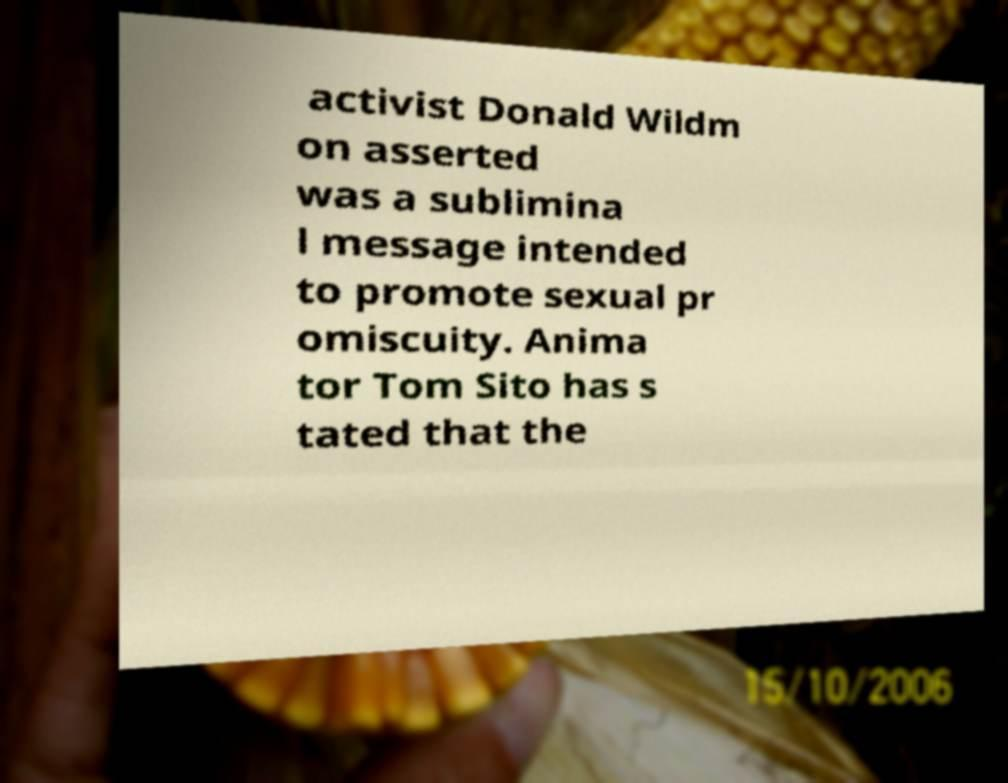I need the written content from this picture converted into text. Can you do that? activist Donald Wildm on asserted was a sublimina l message intended to promote sexual pr omiscuity. Anima tor Tom Sito has s tated that the 